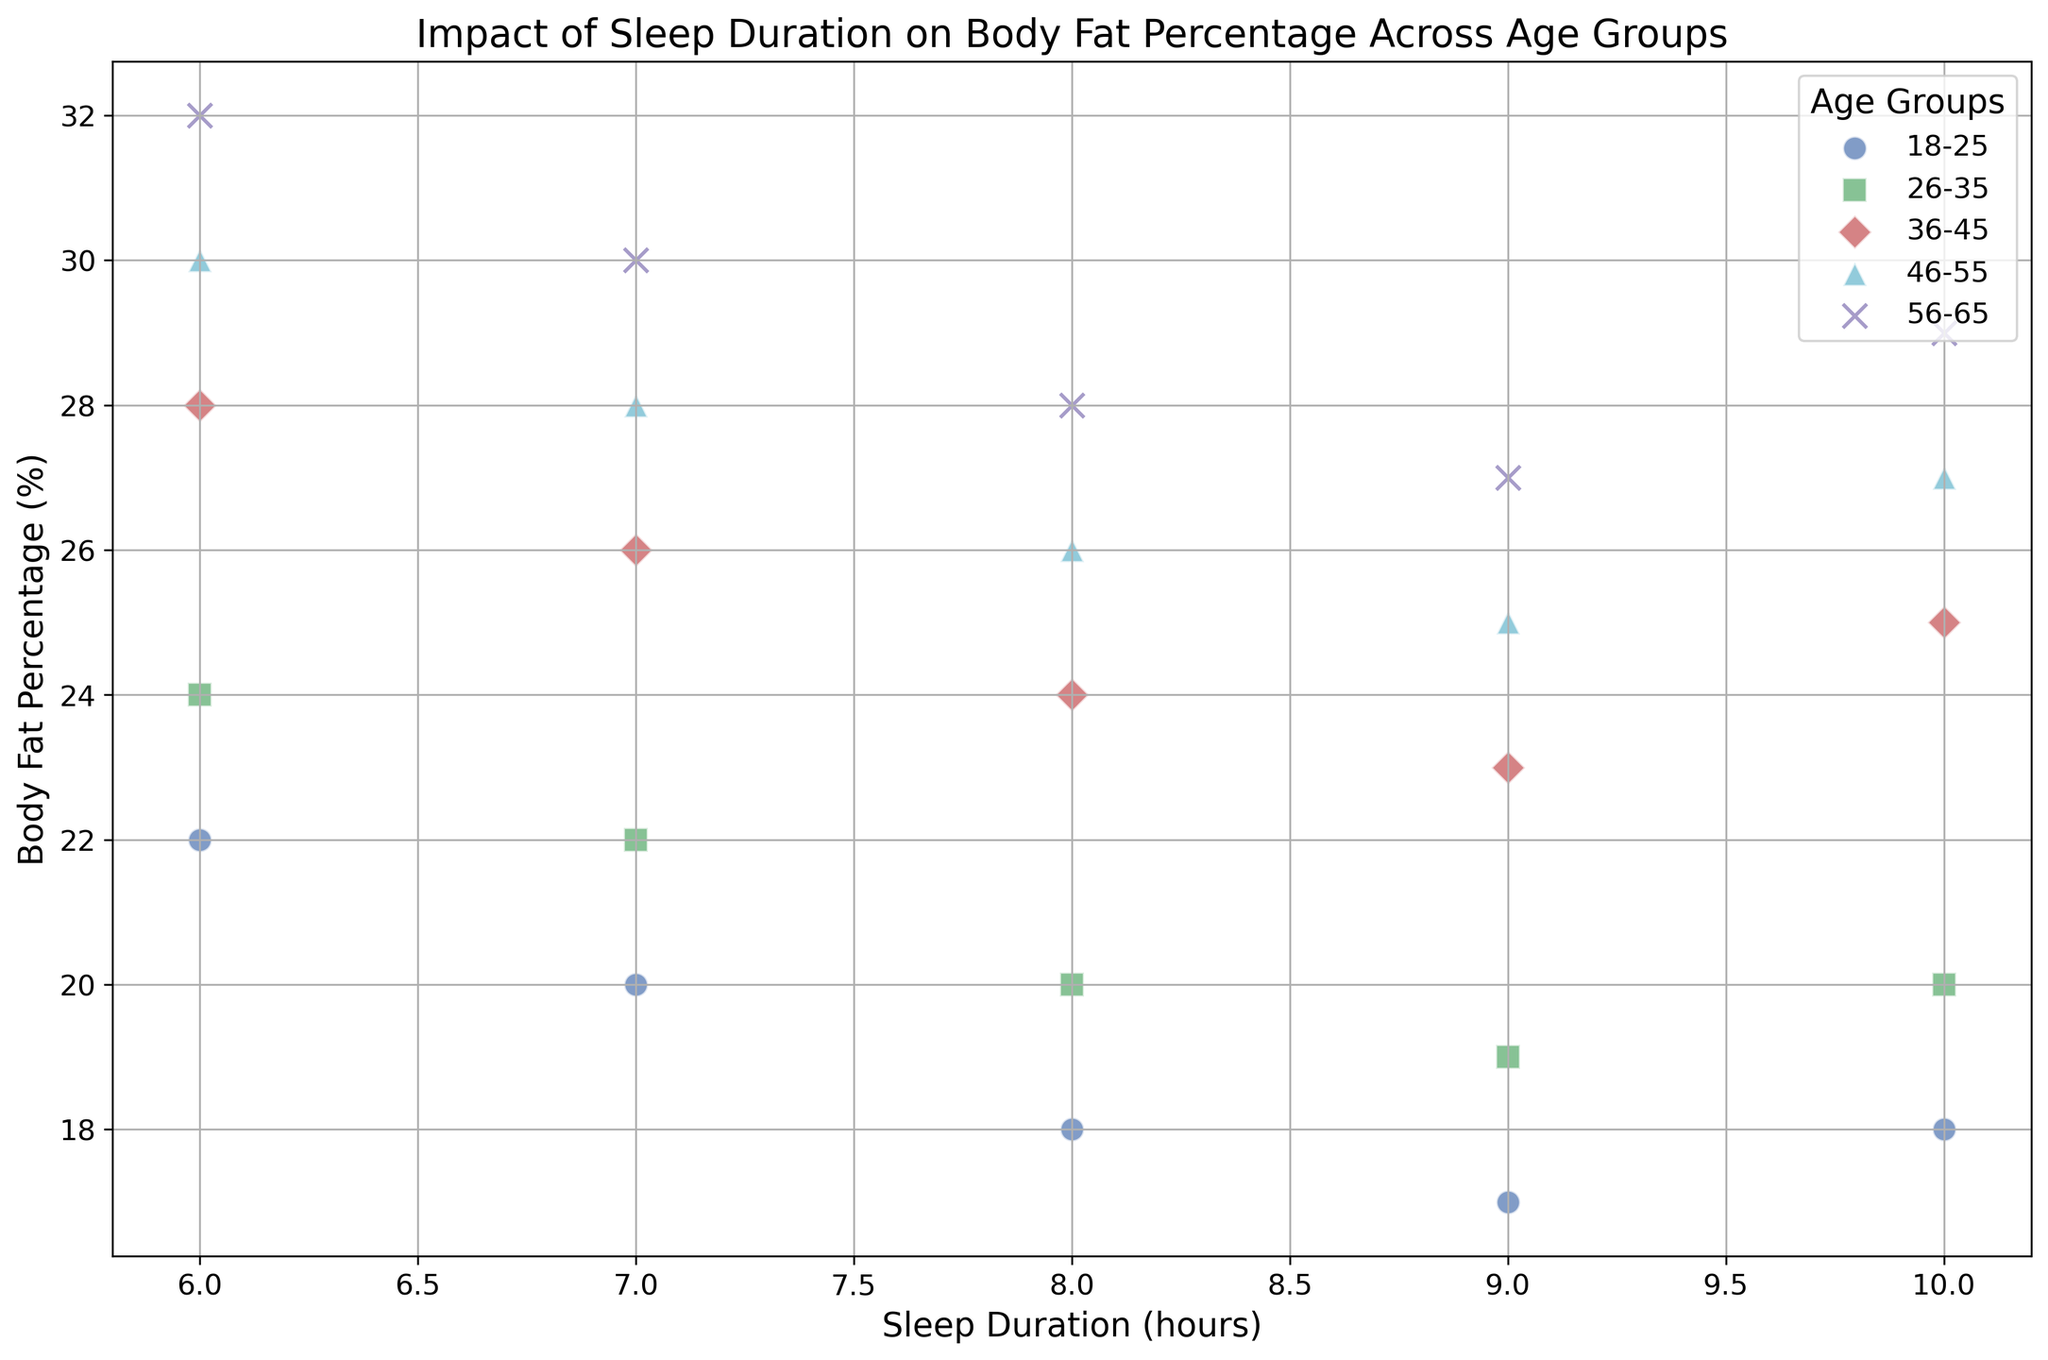Do all age groups show a decrease in body fat percentage with increased sleep duration? To determine this, examine each age group's scatter plot points to establish if the trend is consistently downward. For the 18-25, 26-35, 36-45, and 46-55 age groups, the body fat percentage decreases as sleep duration increases. For the 56-65 age group, body fat percentage mostly decreases but increases slightly at 10 hours.
Answer: Yes, mostly Which age group has the lowest minimum body fat percentage? Compare the minimum body fat percentage across all age groups. The range for 18-25 is 17%, for 26-35 it is 19%, for 36-45 it is 23%, for 46-55 it is 25%, and for 56-65 it is 27%. Therefore, the 18-25 age group has the lowest minimum body fat percentage.
Answer: 18-25 At 8 hours of sleep, which age group has the highest body fat percentage? Examine the body fat percentage values corresponding to 8 hours of sleep for all age groups. The values are: 18%, 20%, 24%, 26%, and 28% for 18-25, 26-35, 36-45, 46-55, and 56-65 respectively. Thus, the 56-65 age group has the highest body fat percentage.
Answer: 56-65 What is the average body fat percentage for the 36-45 age group? Identify the body fat percentages for the 36-45 age group and calculate their average. The values are: 28, 26, 24, 23, 25. Sum is 126, and dividing by 5 gives 25.2.
Answer: 25.2 Which age group shows the greatest range in body fat percentage? Calculate the range of body fat percentages for each age group. The ranges are: 5% (18-25), 5% (26-35), 5% (36-45), 5% (46-55), and 5% (56-65). Equal ranges for all age groups indicate a draw.
Answer: Draw At how many different sleep durations does the 46-55 age group have a higher body fat percentage than the 36-45 age group? Compare the body fat percentages of the 46-55 and 36-45 age groups at each of the sleep durations (6, 7, 8, 9, and 10 hours). The values for 46-55 are 30, 28, 26, 25, 27 and for 36-45 they are 28, 26, 24, 23, 25. The 46-55 age group has higher body fat at all durations: 6, 7, 8, 9, and 10 hours.
Answer: 5 